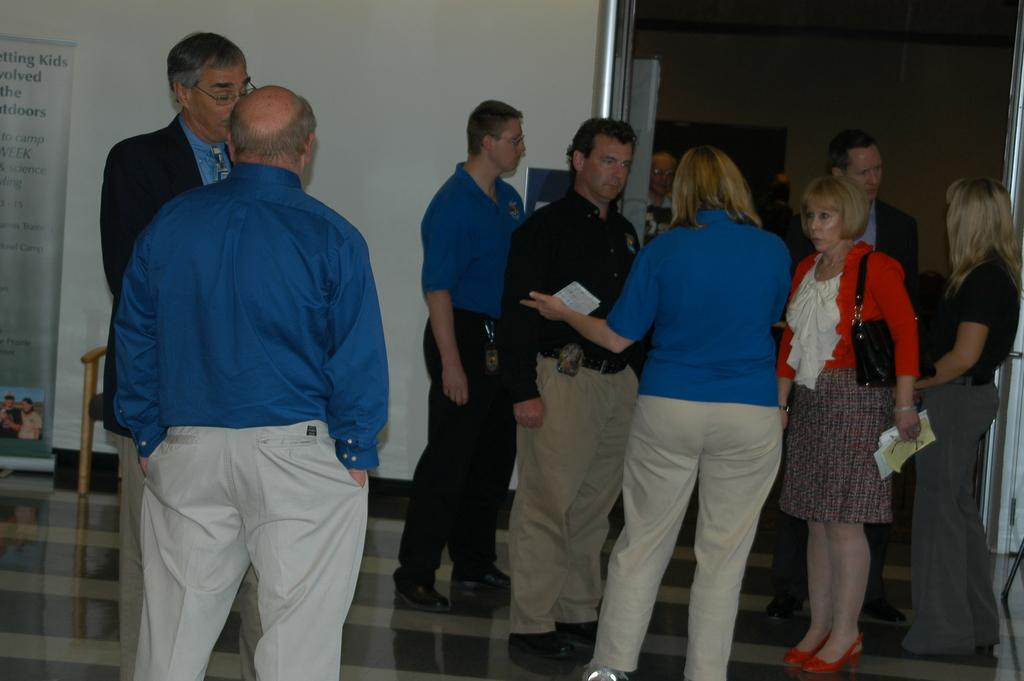What is the main subject in the foreground of the image? There is a bald guy in the foreground of the image. What can be observed about the people in the image? There are many people standing on the floor in the image. What type of snake is slithering through the crowd in the image? There is no snake present in the image; it only features a bald guy and many people standing on the floor. 